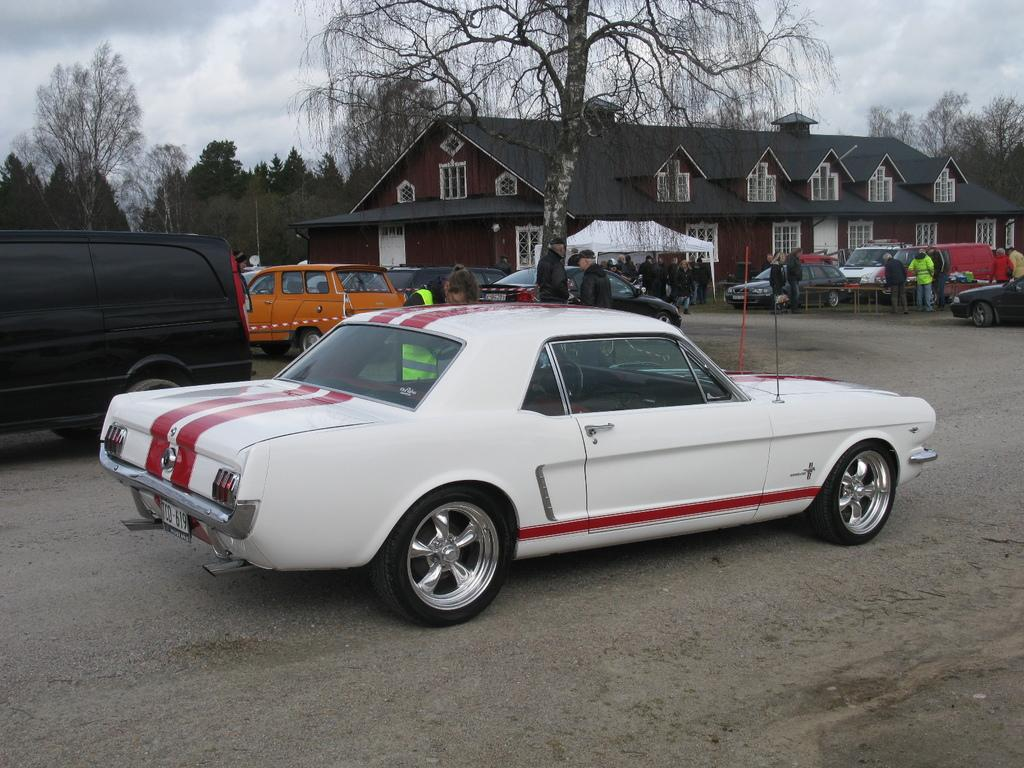What type of building can be seen in the image? There is a house in the image. What natural elements are present in the image? There are trees and plants in the image. What man-made objects can be seen in the image? There are cars in the image. Are there any other people besides the person asking the questions? Yes, there are other people in the image. What key is the father holding in the image? There is no father or key present in the image. 